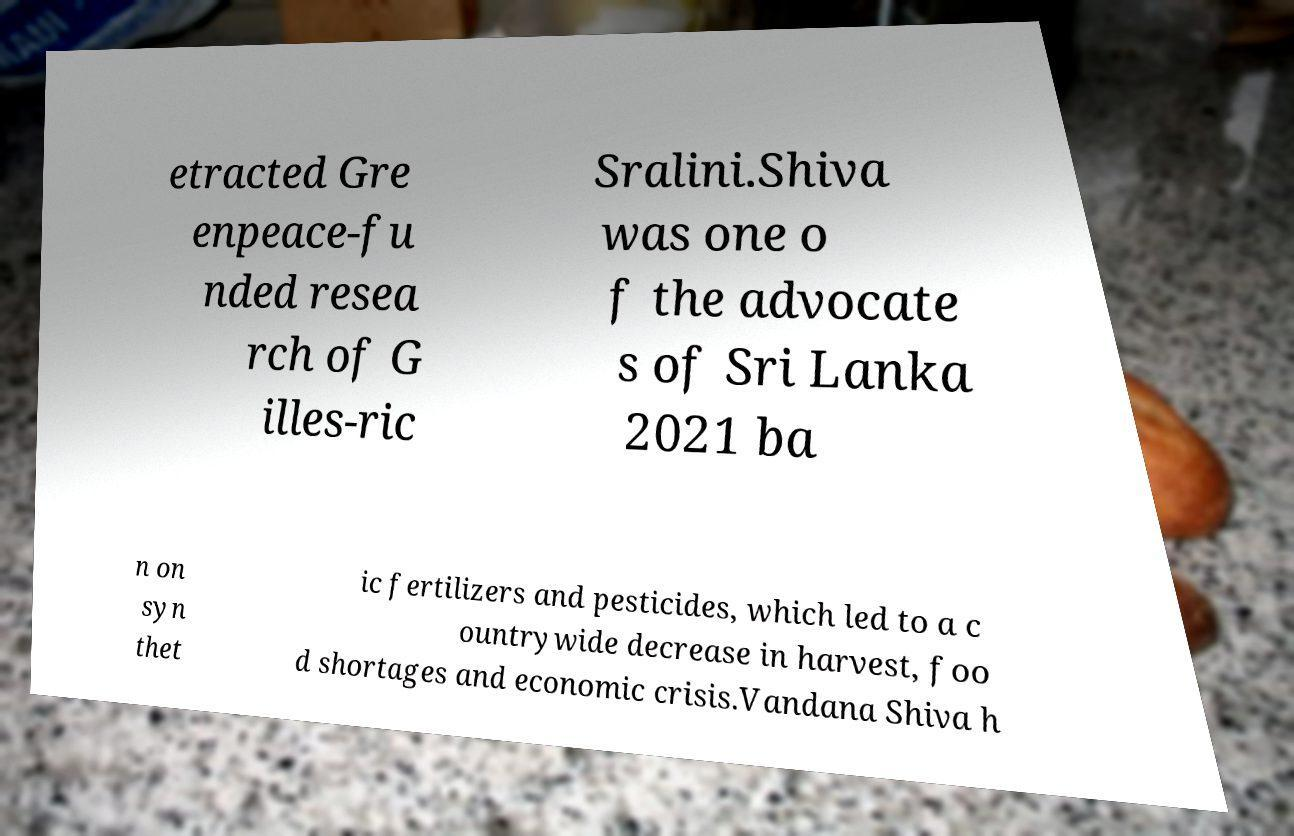Could you extract and type out the text from this image? etracted Gre enpeace-fu nded resea rch of G illes-ric Sralini.Shiva was one o f the advocate s of Sri Lanka 2021 ba n on syn thet ic fertilizers and pesticides, which led to a c ountrywide decrease in harvest, foo d shortages and economic crisis.Vandana Shiva h 